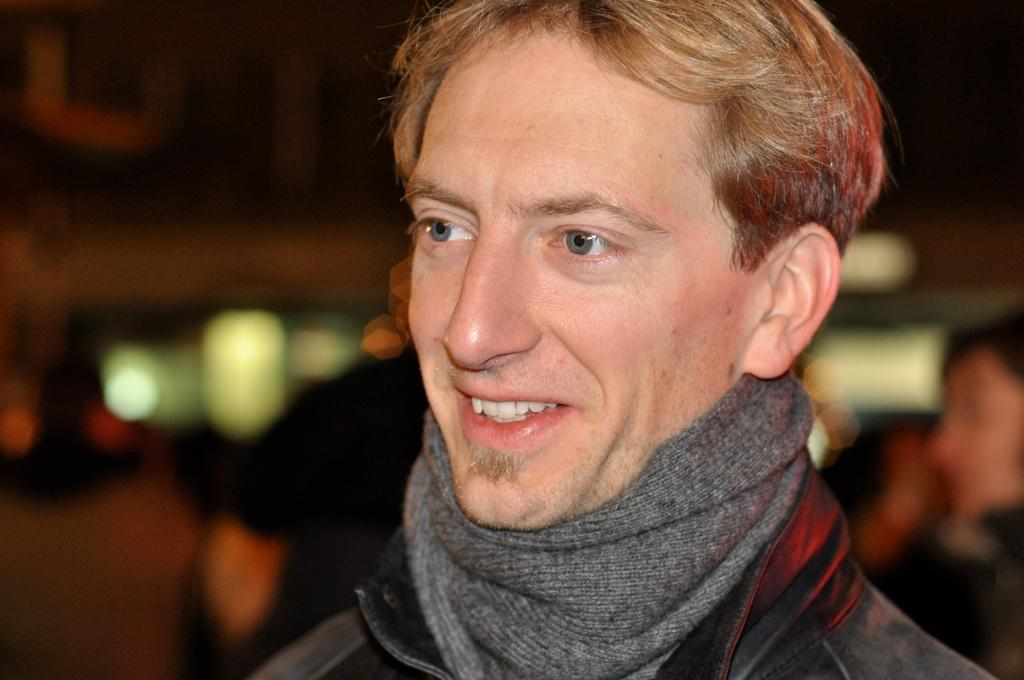Who is the main subject in the image? There is a man in the image. What is the man doing in the image? The man is smiling in the image. Are there any other people in the image besides the man? Yes, there are people standing behind the man. Can you describe the background of the image? The background of the image is blurred. What type of celery can be seen growing on the roof in the image? There is no celery or roof present in the image. Are there any fairies visible in the image? There are no fairies present in the image. 